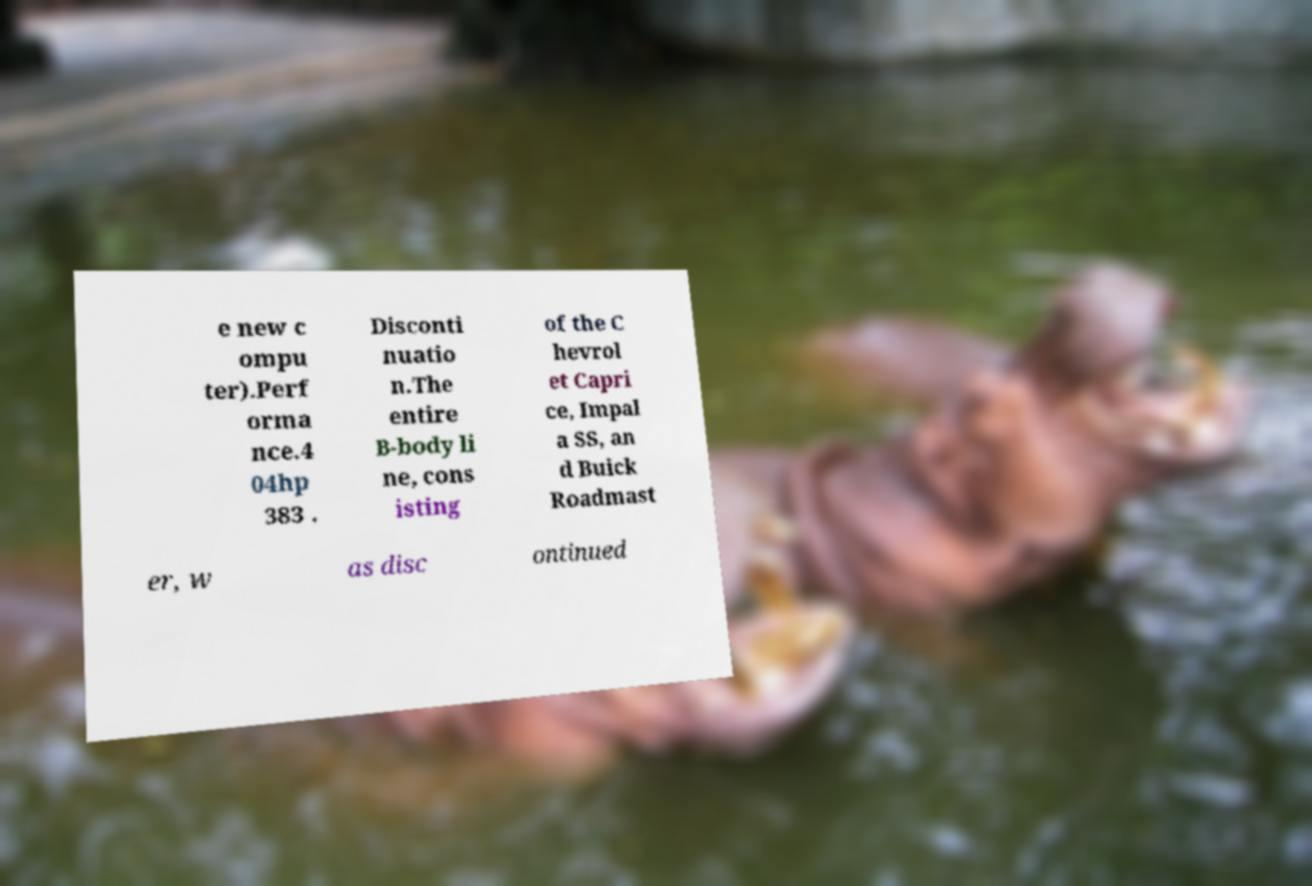Please read and relay the text visible in this image. What does it say? e new c ompu ter).Perf orma nce.4 04hp 383 . Disconti nuatio n.The entire B-body li ne, cons isting of the C hevrol et Capri ce, Impal a SS, an d Buick Roadmast er, w as disc ontinued 